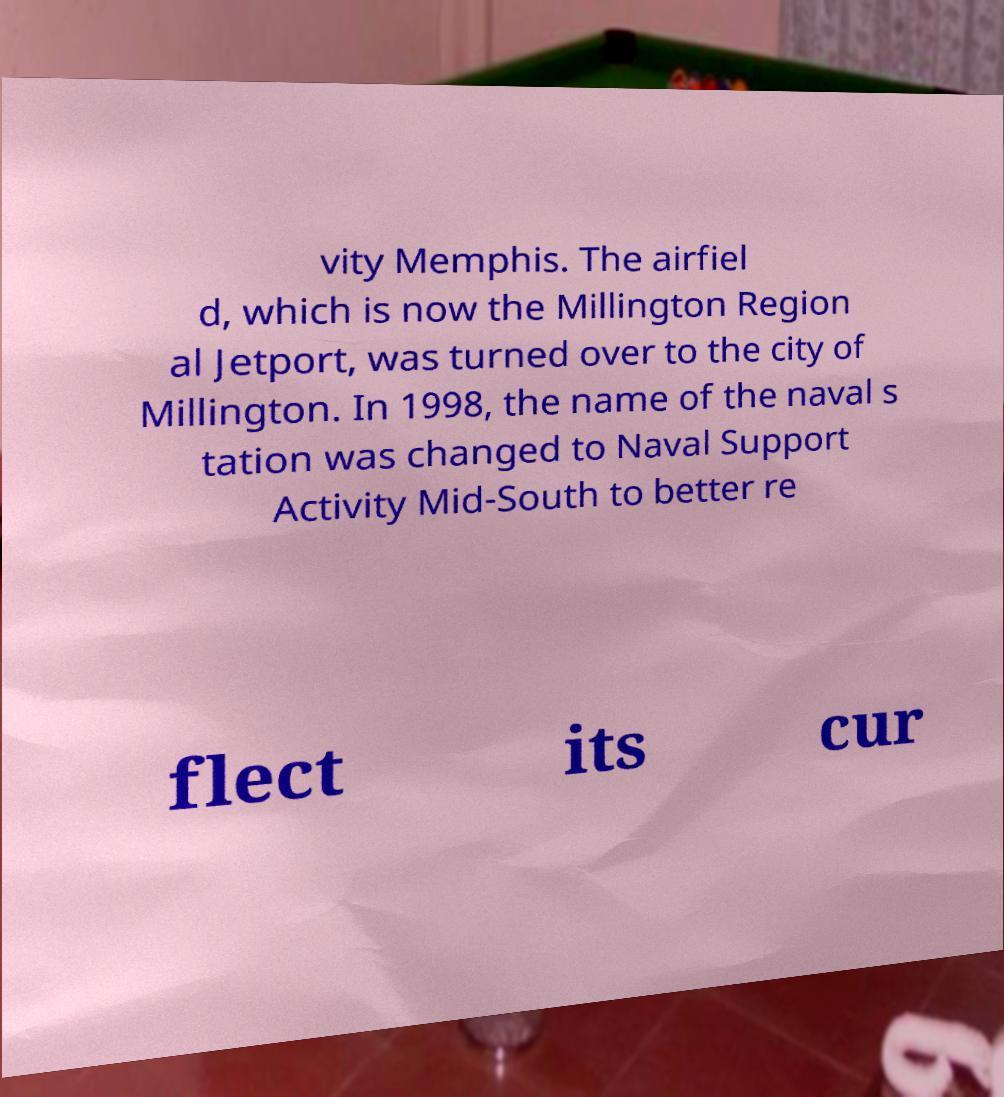I need the written content from this picture converted into text. Can you do that? vity Memphis. The airfiel d, which is now the Millington Region al Jetport, was turned over to the city of Millington. In 1998, the name of the naval s tation was changed to Naval Support Activity Mid-South to better re flect its cur 